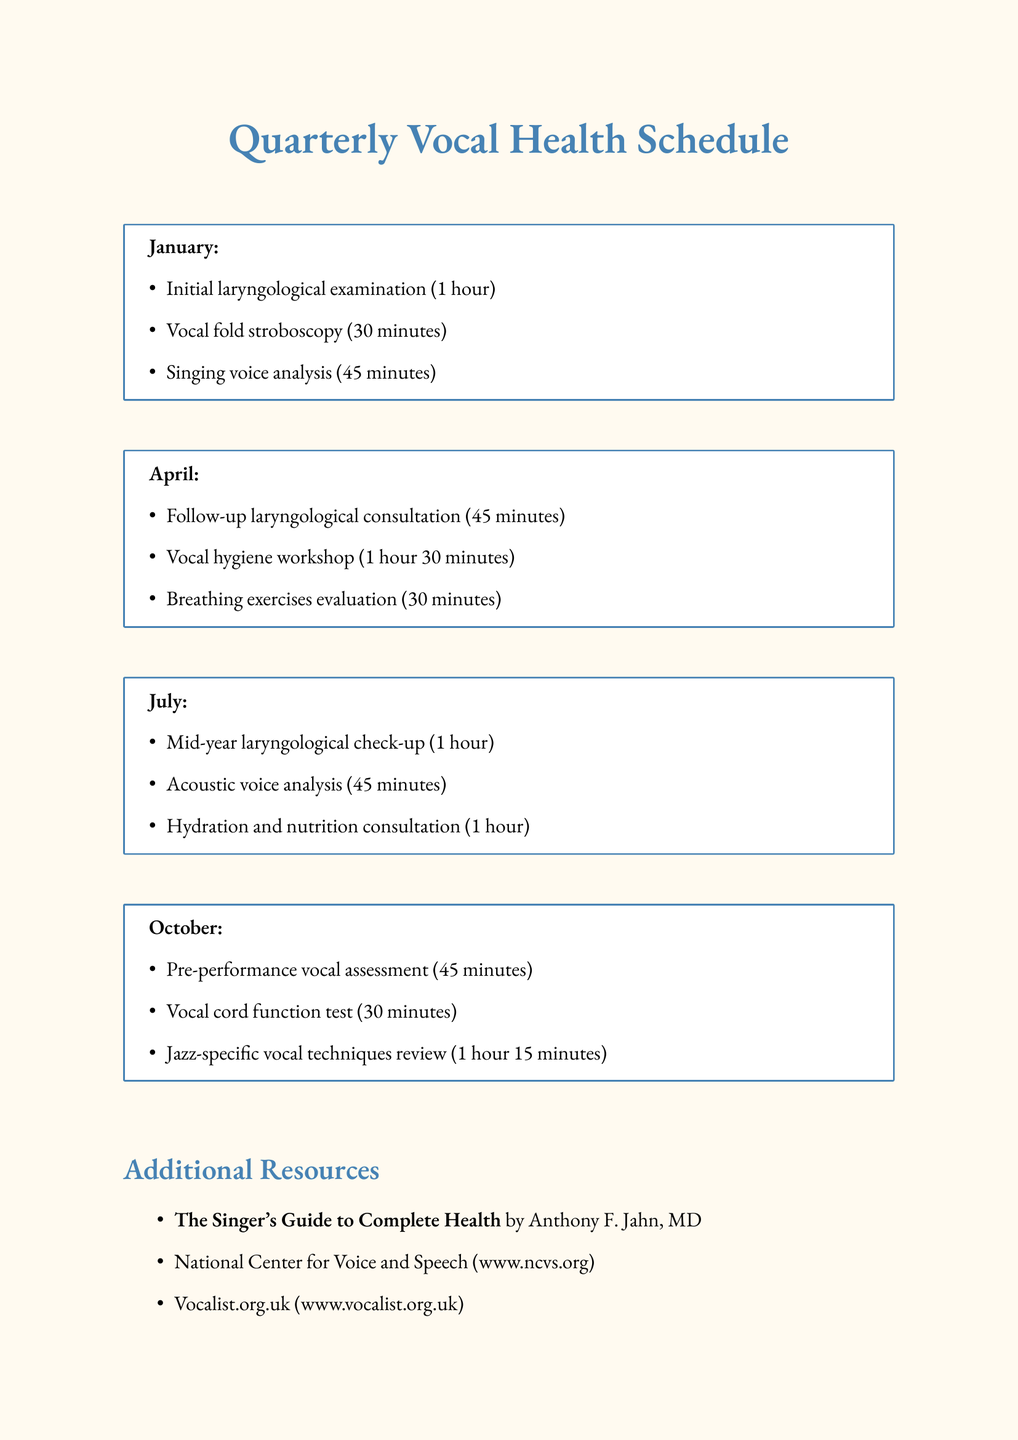What activities are included in January? The activities listed for January can be found in the "quarterly_vocal_health_checkups" section under January.
Answer: Initial laryngological examination, Vocal fold stroboscopy, Singing voice analysis How long is the vocal hygiene workshop? The duration of the vocal hygiene workshop is stated in the April activities.
Answer: 1 hour 30 minutes Who conducts the jazz-specific vocal techniques review? The name of the coach can be found in the October activities section.
Answer: Michael Johnson What sort of test is done in October? The types of tests conducted in October are listed in the activities for that month.
Answer: Vocal cord function test What is the purpose of the breathing exercises evaluation? The description in the April section explains its aim.
Answer: Optimal vocal support How often are vocal health check-ups scheduled? The document specifies the frequency of check-ups in its title.
Answer: Quarterly What is the name of the emergency contact laryngologist? This information is provided under the emergency contacts section.
Answer: Dr. Maria Rodriguez Which online resource is mentioned for vocal health information? The resource can be found in the additional resources section.
Answer: National Center for Voice and Speech How long is the initial laryngological examination? The duration is listed alongside the activity in January's section.
Answer: 1 hour 